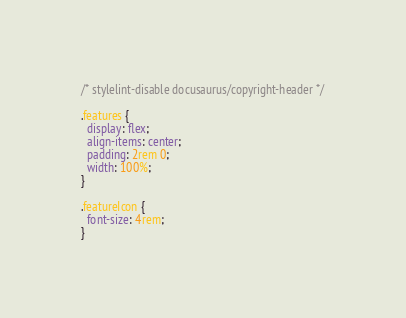<code> <loc_0><loc_0><loc_500><loc_500><_CSS_>/* stylelint-disable docusaurus/copyright-header */

.features {
  display: flex;
  align-items: center;
  padding: 2rem 0;
  width: 100%;
}

.featureIcon {
  font-size: 4rem;
}
</code> 